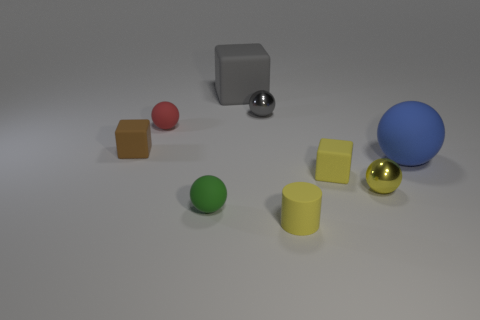How many gray rubber cubes are the same size as the yellow block?
Give a very brief answer. 0. There is a rubber thing that is the same color as the cylinder; what shape is it?
Provide a short and direct response. Cube. Are there any tiny green rubber things that have the same shape as the large blue matte thing?
Offer a very short reply. Yes. The matte ball that is the same size as the gray rubber object is what color?
Keep it short and to the point. Blue. There is a small matte block that is on the left side of the large rubber thing that is left of the gray ball; what is its color?
Provide a short and direct response. Brown. There is a small metallic thing in front of the gray metallic thing; does it have the same color as the big rubber sphere?
Keep it short and to the point. No. There is a gray object that is in front of the rubber cube behind the metallic ball behind the small brown thing; what shape is it?
Provide a succinct answer. Sphere. What number of red spheres are behind the shiny object that is on the left side of the tiny matte cylinder?
Offer a terse response. 0. Is the small gray object made of the same material as the big cube?
Make the answer very short. No. There is a yellow thing behind the small metal object right of the gray metal sphere; what number of tiny matte cylinders are in front of it?
Your response must be concise. 1. 